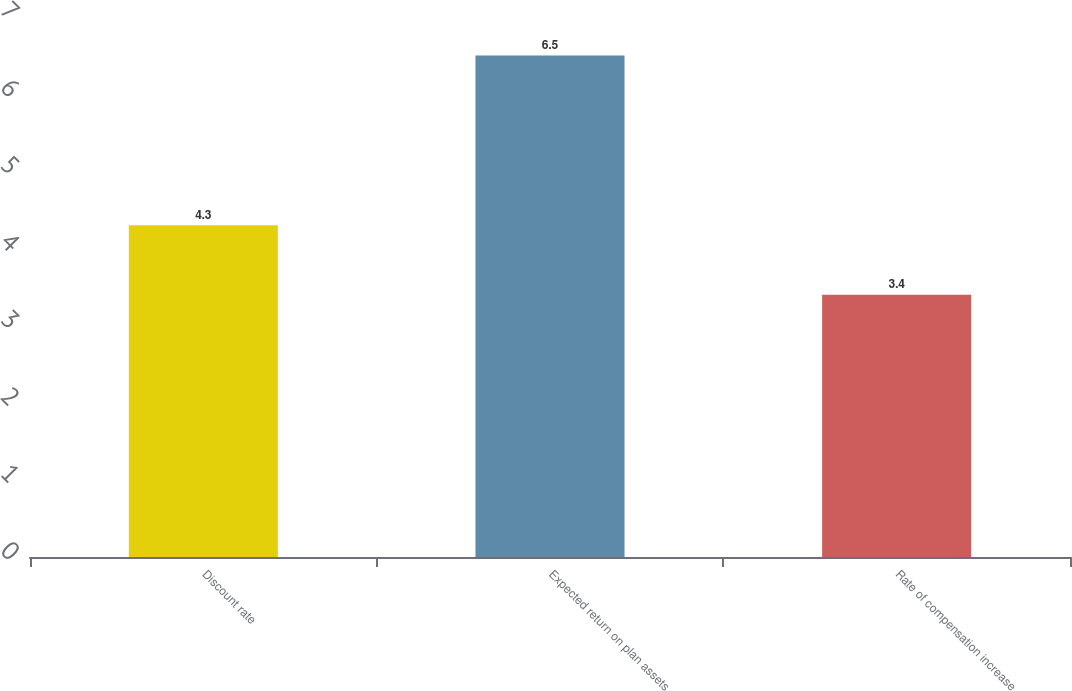<chart> <loc_0><loc_0><loc_500><loc_500><bar_chart><fcel>Discount rate<fcel>Expected return on plan assets<fcel>Rate of compensation increase<nl><fcel>4.3<fcel>6.5<fcel>3.4<nl></chart> 